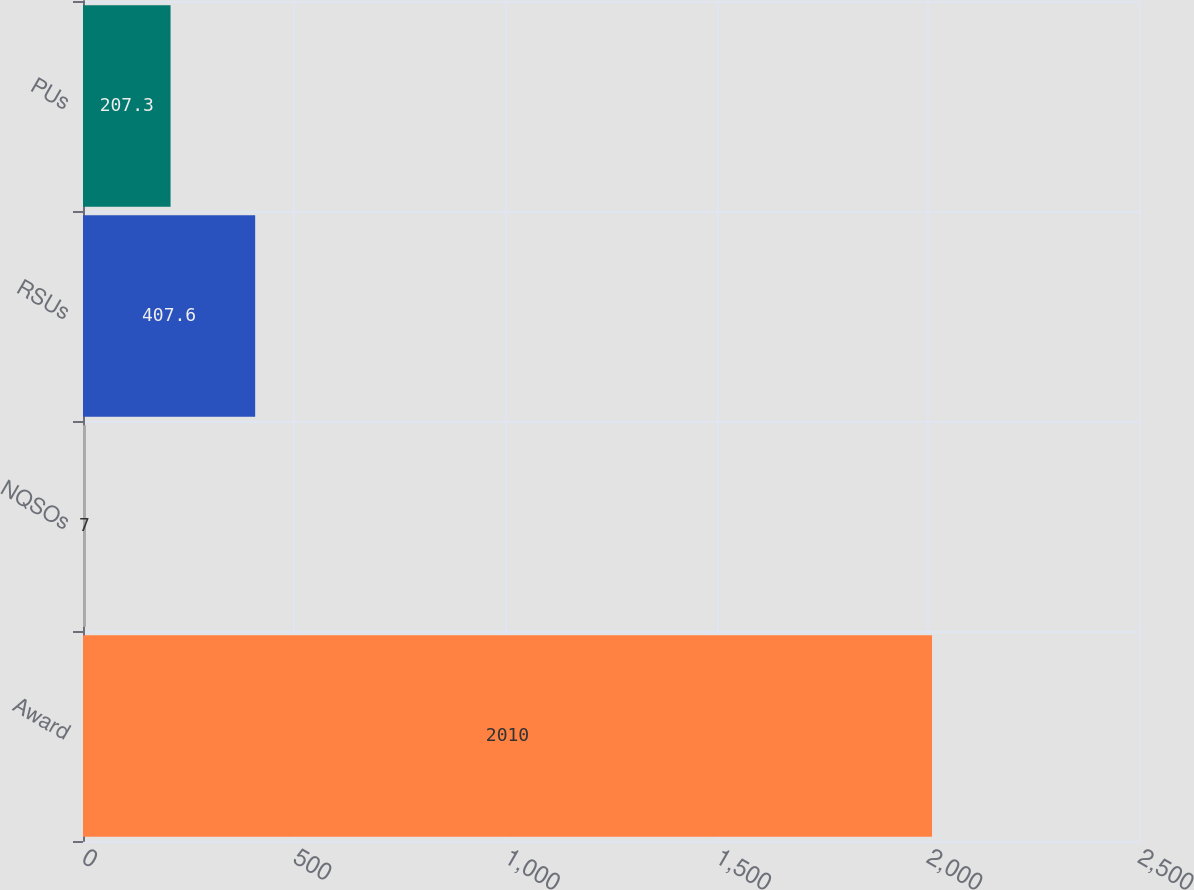Convert chart. <chart><loc_0><loc_0><loc_500><loc_500><bar_chart><fcel>Award<fcel>NQSOs<fcel>RSUs<fcel>PUs<nl><fcel>2010<fcel>7<fcel>407.6<fcel>207.3<nl></chart> 